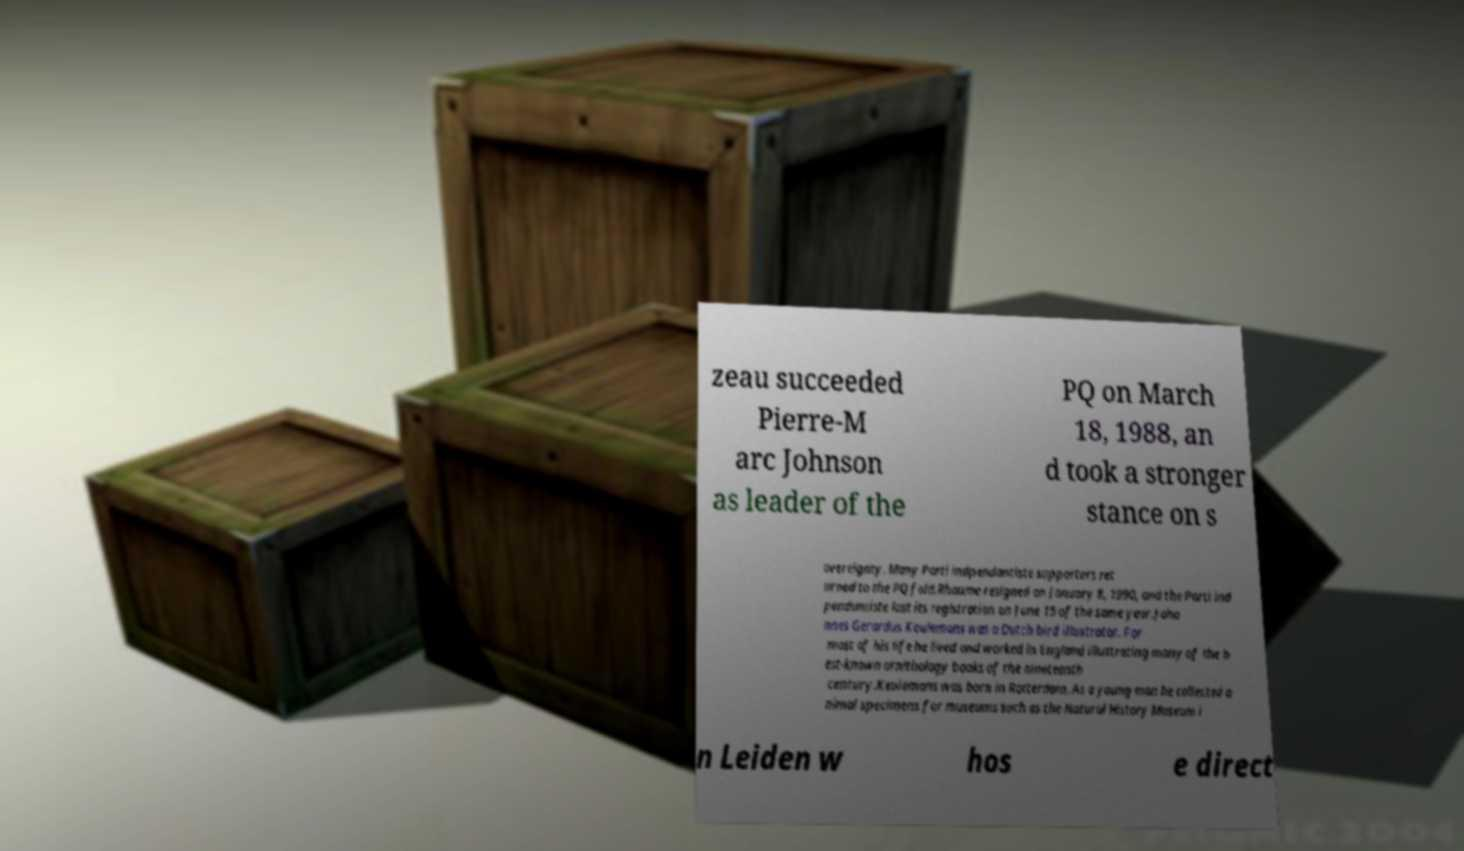Could you assist in decoding the text presented in this image and type it out clearly? zeau succeeded Pierre-M arc Johnson as leader of the PQ on March 18, 1988, an d took a stronger stance on s overeignty. Many Parti indpendantiste supporters ret urned to the PQ fold.Rhaume resigned on January 8, 1990, and the Parti ind pendantiste lost its registration on June 15 of the same year.Joha nnes Gerardus Keulemans was a Dutch bird illustrator. For most of his life he lived and worked in England illustrating many of the b est-known ornithology books of the nineteenth century.Keulemans was born in Rotterdam. As a young man he collected a nimal specimens for museums such as the Natural History Museum i n Leiden w hos e direct 